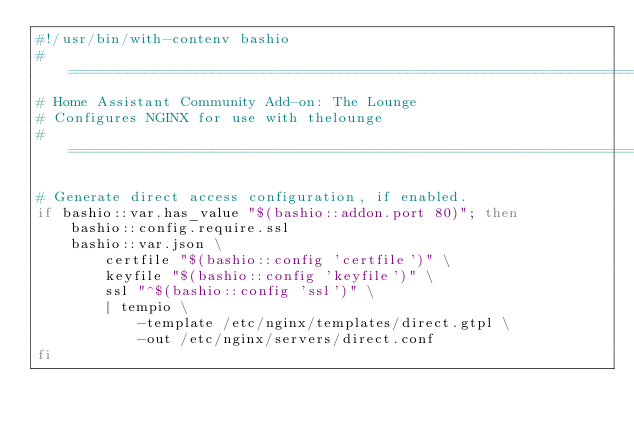<code> <loc_0><loc_0><loc_500><loc_500><_Bash_>#!/usr/bin/with-contenv bashio
# ==============================================================================
# Home Assistant Community Add-on: The Lounge
# Configures NGINX for use with thelounge
# ==============================================================================

# Generate direct access configuration, if enabled.
if bashio::var.has_value "$(bashio::addon.port 80)"; then
    bashio::config.require.ssl
    bashio::var.json \
        certfile "$(bashio::config 'certfile')" \
        keyfile "$(bashio::config 'keyfile')" \
        ssl "^$(bashio::config 'ssl')" \
        | tempio \
            -template /etc/nginx/templates/direct.gtpl \
            -out /etc/nginx/servers/direct.conf
fi
</code> 